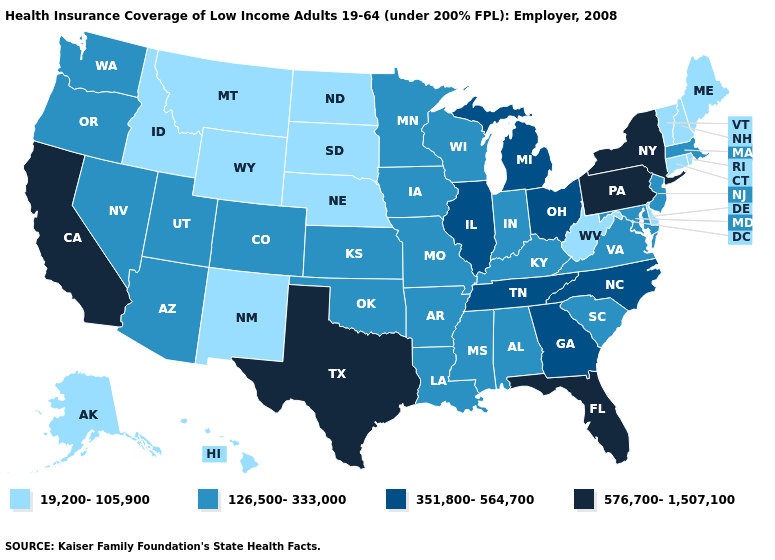Name the states that have a value in the range 19,200-105,900?
Quick response, please. Alaska, Connecticut, Delaware, Hawaii, Idaho, Maine, Montana, Nebraska, New Hampshire, New Mexico, North Dakota, Rhode Island, South Dakota, Vermont, West Virginia, Wyoming. Does Virginia have the lowest value in the USA?
Concise answer only. No. Among the states that border Oklahoma , which have the highest value?
Give a very brief answer. Texas. Does the map have missing data?
Concise answer only. No. Which states have the lowest value in the USA?
Give a very brief answer. Alaska, Connecticut, Delaware, Hawaii, Idaho, Maine, Montana, Nebraska, New Hampshire, New Mexico, North Dakota, Rhode Island, South Dakota, Vermont, West Virginia, Wyoming. Does the map have missing data?
Write a very short answer. No. Name the states that have a value in the range 351,800-564,700?
Give a very brief answer. Georgia, Illinois, Michigan, North Carolina, Ohio, Tennessee. Name the states that have a value in the range 576,700-1,507,100?
Keep it brief. California, Florida, New York, Pennsylvania, Texas. What is the value of New Mexico?
Keep it brief. 19,200-105,900. What is the lowest value in the USA?
Give a very brief answer. 19,200-105,900. Which states have the highest value in the USA?
Answer briefly. California, Florida, New York, Pennsylvania, Texas. Name the states that have a value in the range 19,200-105,900?
Short answer required. Alaska, Connecticut, Delaware, Hawaii, Idaho, Maine, Montana, Nebraska, New Hampshire, New Mexico, North Dakota, Rhode Island, South Dakota, Vermont, West Virginia, Wyoming. Name the states that have a value in the range 19,200-105,900?
Answer briefly. Alaska, Connecticut, Delaware, Hawaii, Idaho, Maine, Montana, Nebraska, New Hampshire, New Mexico, North Dakota, Rhode Island, South Dakota, Vermont, West Virginia, Wyoming. What is the lowest value in the Northeast?
Quick response, please. 19,200-105,900. Which states have the highest value in the USA?
Concise answer only. California, Florida, New York, Pennsylvania, Texas. 